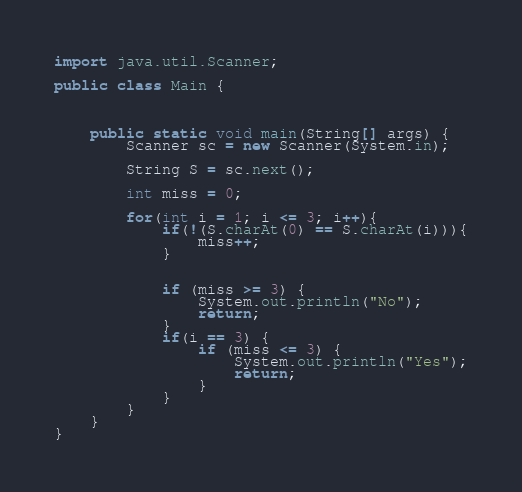Convert code to text. <code><loc_0><loc_0><loc_500><loc_500><_Java_>
import java.util.Scanner;

public class Main {



    public static void main(String[] args) {
        Scanner sc = new Scanner(System.in);

        String S = sc.next();

        int miss = 0;

        for(int i = 1; i <= 3; i++){
            if(!(S.charAt(0) == S.charAt(i))){
                miss++;
            }


            if (miss >= 3) {
                System.out.println("No");
                return;
            }
            if(i == 3) {
                if (miss <= 3) {
                    System.out.println("Yes");
                    return;
                }
            }
        }
    }
}
</code> 